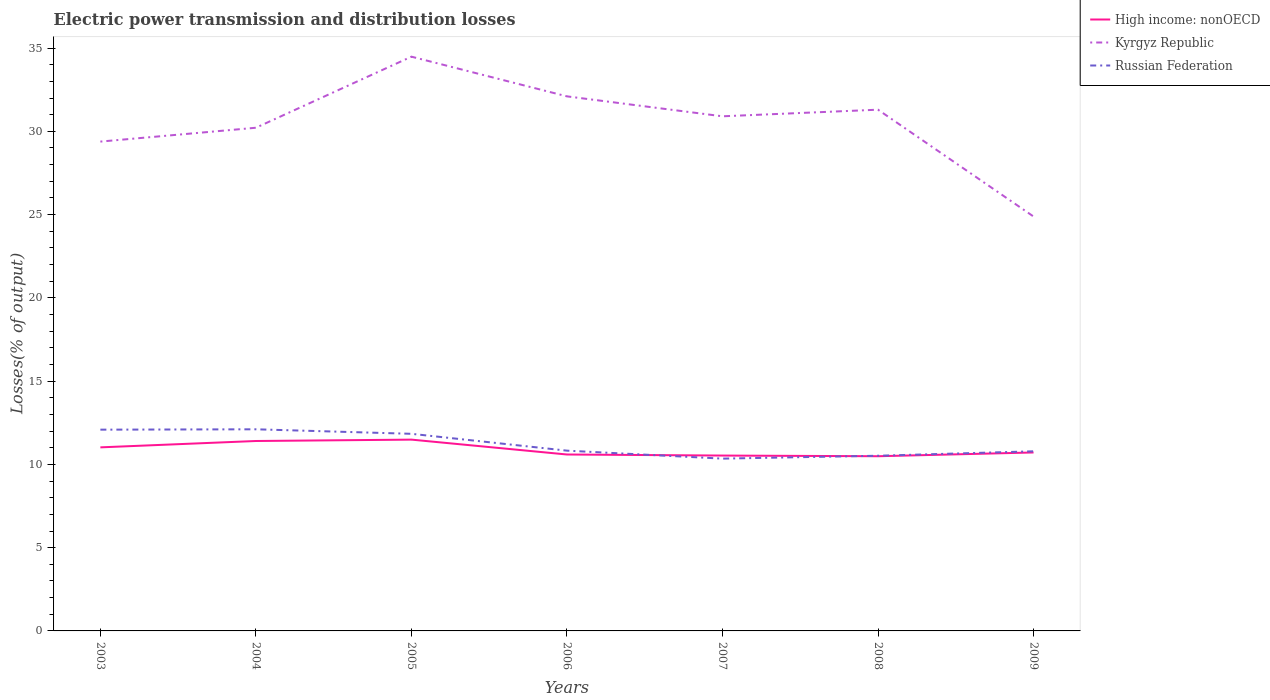Does the line corresponding to Kyrgyz Republic intersect with the line corresponding to High income: nonOECD?
Give a very brief answer. No. Is the number of lines equal to the number of legend labels?
Your response must be concise. Yes. Across all years, what is the maximum electric power transmission and distribution losses in Russian Federation?
Your answer should be compact. 10.35. In which year was the electric power transmission and distribution losses in High income: nonOECD maximum?
Your response must be concise. 2008. What is the total electric power transmission and distribution losses in Russian Federation in the graph?
Your answer should be very brief. -0.02. What is the difference between the highest and the second highest electric power transmission and distribution losses in Kyrgyz Republic?
Offer a very short reply. 9.6. What is the difference between the highest and the lowest electric power transmission and distribution losses in Russian Federation?
Keep it short and to the point. 3. Are the values on the major ticks of Y-axis written in scientific E-notation?
Offer a very short reply. No. Does the graph contain any zero values?
Your answer should be very brief. No. How are the legend labels stacked?
Your response must be concise. Vertical. What is the title of the graph?
Offer a very short reply. Electric power transmission and distribution losses. Does "Belarus" appear as one of the legend labels in the graph?
Offer a very short reply. No. What is the label or title of the X-axis?
Make the answer very short. Years. What is the label or title of the Y-axis?
Make the answer very short. Losses(% of output). What is the Losses(% of output) of High income: nonOECD in 2003?
Your response must be concise. 11.02. What is the Losses(% of output) in Kyrgyz Republic in 2003?
Your answer should be compact. 29.38. What is the Losses(% of output) in Russian Federation in 2003?
Provide a succinct answer. 12.09. What is the Losses(% of output) of High income: nonOECD in 2004?
Offer a very short reply. 11.4. What is the Losses(% of output) of Kyrgyz Republic in 2004?
Ensure brevity in your answer.  30.22. What is the Losses(% of output) of Russian Federation in 2004?
Ensure brevity in your answer.  12.11. What is the Losses(% of output) in High income: nonOECD in 2005?
Offer a terse response. 11.49. What is the Losses(% of output) in Kyrgyz Republic in 2005?
Offer a very short reply. 34.48. What is the Losses(% of output) of Russian Federation in 2005?
Ensure brevity in your answer.  11.84. What is the Losses(% of output) of High income: nonOECD in 2006?
Offer a very short reply. 10.59. What is the Losses(% of output) in Kyrgyz Republic in 2006?
Offer a very short reply. 32.1. What is the Losses(% of output) of Russian Federation in 2006?
Make the answer very short. 10.83. What is the Losses(% of output) of High income: nonOECD in 2007?
Ensure brevity in your answer.  10.53. What is the Losses(% of output) of Kyrgyz Republic in 2007?
Offer a very short reply. 30.9. What is the Losses(% of output) of Russian Federation in 2007?
Ensure brevity in your answer.  10.35. What is the Losses(% of output) in High income: nonOECD in 2008?
Provide a short and direct response. 10.49. What is the Losses(% of output) in Kyrgyz Republic in 2008?
Your response must be concise. 31.3. What is the Losses(% of output) in Russian Federation in 2008?
Offer a very short reply. 10.52. What is the Losses(% of output) in High income: nonOECD in 2009?
Your answer should be compact. 10.72. What is the Losses(% of output) of Kyrgyz Republic in 2009?
Keep it short and to the point. 24.88. What is the Losses(% of output) of Russian Federation in 2009?
Your answer should be very brief. 10.79. Across all years, what is the maximum Losses(% of output) of High income: nonOECD?
Provide a short and direct response. 11.49. Across all years, what is the maximum Losses(% of output) in Kyrgyz Republic?
Keep it short and to the point. 34.48. Across all years, what is the maximum Losses(% of output) in Russian Federation?
Keep it short and to the point. 12.11. Across all years, what is the minimum Losses(% of output) of High income: nonOECD?
Offer a very short reply. 10.49. Across all years, what is the minimum Losses(% of output) of Kyrgyz Republic?
Keep it short and to the point. 24.88. Across all years, what is the minimum Losses(% of output) of Russian Federation?
Provide a succinct answer. 10.35. What is the total Losses(% of output) in High income: nonOECD in the graph?
Offer a very short reply. 76.25. What is the total Losses(% of output) of Kyrgyz Republic in the graph?
Your answer should be compact. 213.27. What is the total Losses(% of output) in Russian Federation in the graph?
Keep it short and to the point. 78.51. What is the difference between the Losses(% of output) in High income: nonOECD in 2003 and that in 2004?
Offer a terse response. -0.38. What is the difference between the Losses(% of output) of Kyrgyz Republic in 2003 and that in 2004?
Make the answer very short. -0.83. What is the difference between the Losses(% of output) in Russian Federation in 2003 and that in 2004?
Provide a succinct answer. -0.02. What is the difference between the Losses(% of output) in High income: nonOECD in 2003 and that in 2005?
Offer a terse response. -0.46. What is the difference between the Losses(% of output) of Kyrgyz Republic in 2003 and that in 2005?
Give a very brief answer. -5.1. What is the difference between the Losses(% of output) of Russian Federation in 2003 and that in 2005?
Provide a short and direct response. 0.25. What is the difference between the Losses(% of output) in High income: nonOECD in 2003 and that in 2006?
Your answer should be compact. 0.43. What is the difference between the Losses(% of output) in Kyrgyz Republic in 2003 and that in 2006?
Your answer should be compact. -2.72. What is the difference between the Losses(% of output) of Russian Federation in 2003 and that in 2006?
Give a very brief answer. 1.26. What is the difference between the Losses(% of output) in High income: nonOECD in 2003 and that in 2007?
Provide a succinct answer. 0.49. What is the difference between the Losses(% of output) in Kyrgyz Republic in 2003 and that in 2007?
Your answer should be compact. -1.52. What is the difference between the Losses(% of output) in Russian Federation in 2003 and that in 2007?
Keep it short and to the point. 1.74. What is the difference between the Losses(% of output) in High income: nonOECD in 2003 and that in 2008?
Keep it short and to the point. 0.53. What is the difference between the Losses(% of output) of Kyrgyz Republic in 2003 and that in 2008?
Keep it short and to the point. -1.92. What is the difference between the Losses(% of output) in Russian Federation in 2003 and that in 2008?
Your response must be concise. 1.57. What is the difference between the Losses(% of output) of High income: nonOECD in 2003 and that in 2009?
Ensure brevity in your answer.  0.31. What is the difference between the Losses(% of output) in Kyrgyz Republic in 2003 and that in 2009?
Offer a terse response. 4.5. What is the difference between the Losses(% of output) in Russian Federation in 2003 and that in 2009?
Provide a short and direct response. 1.3. What is the difference between the Losses(% of output) in High income: nonOECD in 2004 and that in 2005?
Provide a short and direct response. -0.08. What is the difference between the Losses(% of output) of Kyrgyz Republic in 2004 and that in 2005?
Offer a very short reply. -4.27. What is the difference between the Losses(% of output) in Russian Federation in 2004 and that in 2005?
Provide a short and direct response. 0.27. What is the difference between the Losses(% of output) in High income: nonOECD in 2004 and that in 2006?
Your answer should be compact. 0.81. What is the difference between the Losses(% of output) in Kyrgyz Republic in 2004 and that in 2006?
Your answer should be compact. -1.88. What is the difference between the Losses(% of output) in Russian Federation in 2004 and that in 2006?
Give a very brief answer. 1.28. What is the difference between the Losses(% of output) in High income: nonOECD in 2004 and that in 2007?
Provide a short and direct response. 0.87. What is the difference between the Losses(% of output) of Kyrgyz Republic in 2004 and that in 2007?
Offer a very short reply. -0.69. What is the difference between the Losses(% of output) of Russian Federation in 2004 and that in 2007?
Give a very brief answer. 1.76. What is the difference between the Losses(% of output) of High income: nonOECD in 2004 and that in 2008?
Provide a succinct answer. 0.92. What is the difference between the Losses(% of output) of Kyrgyz Republic in 2004 and that in 2008?
Your answer should be very brief. -1.08. What is the difference between the Losses(% of output) in Russian Federation in 2004 and that in 2008?
Provide a succinct answer. 1.59. What is the difference between the Losses(% of output) in High income: nonOECD in 2004 and that in 2009?
Offer a very short reply. 0.69. What is the difference between the Losses(% of output) in Kyrgyz Republic in 2004 and that in 2009?
Provide a succinct answer. 5.33. What is the difference between the Losses(% of output) in Russian Federation in 2004 and that in 2009?
Provide a succinct answer. 1.32. What is the difference between the Losses(% of output) of High income: nonOECD in 2005 and that in 2006?
Offer a terse response. 0.89. What is the difference between the Losses(% of output) of Kyrgyz Republic in 2005 and that in 2006?
Offer a very short reply. 2.38. What is the difference between the Losses(% of output) in Russian Federation in 2005 and that in 2006?
Your answer should be very brief. 1.01. What is the difference between the Losses(% of output) of High income: nonOECD in 2005 and that in 2007?
Provide a short and direct response. 0.96. What is the difference between the Losses(% of output) of Kyrgyz Republic in 2005 and that in 2007?
Give a very brief answer. 3.58. What is the difference between the Losses(% of output) in Russian Federation in 2005 and that in 2007?
Provide a short and direct response. 1.49. What is the difference between the Losses(% of output) in Kyrgyz Republic in 2005 and that in 2008?
Provide a short and direct response. 3.18. What is the difference between the Losses(% of output) of Russian Federation in 2005 and that in 2008?
Your response must be concise. 1.32. What is the difference between the Losses(% of output) of High income: nonOECD in 2005 and that in 2009?
Your response must be concise. 0.77. What is the difference between the Losses(% of output) in Kyrgyz Republic in 2005 and that in 2009?
Your answer should be compact. 9.6. What is the difference between the Losses(% of output) of Russian Federation in 2005 and that in 2009?
Keep it short and to the point. 1.05. What is the difference between the Losses(% of output) in High income: nonOECD in 2006 and that in 2007?
Offer a very short reply. 0.06. What is the difference between the Losses(% of output) of Kyrgyz Republic in 2006 and that in 2007?
Offer a very short reply. 1.2. What is the difference between the Losses(% of output) of Russian Federation in 2006 and that in 2007?
Make the answer very short. 0.48. What is the difference between the Losses(% of output) of High income: nonOECD in 2006 and that in 2008?
Ensure brevity in your answer.  0.1. What is the difference between the Losses(% of output) in Kyrgyz Republic in 2006 and that in 2008?
Offer a very short reply. 0.8. What is the difference between the Losses(% of output) in Russian Federation in 2006 and that in 2008?
Your response must be concise. 0.31. What is the difference between the Losses(% of output) in High income: nonOECD in 2006 and that in 2009?
Your answer should be very brief. -0.12. What is the difference between the Losses(% of output) in Kyrgyz Republic in 2006 and that in 2009?
Provide a succinct answer. 7.22. What is the difference between the Losses(% of output) in Russian Federation in 2006 and that in 2009?
Make the answer very short. 0.04. What is the difference between the Losses(% of output) of High income: nonOECD in 2007 and that in 2008?
Offer a very short reply. 0.04. What is the difference between the Losses(% of output) in Kyrgyz Republic in 2007 and that in 2008?
Your answer should be very brief. -0.4. What is the difference between the Losses(% of output) in Russian Federation in 2007 and that in 2008?
Make the answer very short. -0.17. What is the difference between the Losses(% of output) of High income: nonOECD in 2007 and that in 2009?
Your answer should be very brief. -0.19. What is the difference between the Losses(% of output) in Kyrgyz Republic in 2007 and that in 2009?
Offer a very short reply. 6.02. What is the difference between the Losses(% of output) of Russian Federation in 2007 and that in 2009?
Give a very brief answer. -0.44. What is the difference between the Losses(% of output) in High income: nonOECD in 2008 and that in 2009?
Make the answer very short. -0.23. What is the difference between the Losses(% of output) in Kyrgyz Republic in 2008 and that in 2009?
Make the answer very short. 6.42. What is the difference between the Losses(% of output) of Russian Federation in 2008 and that in 2009?
Provide a short and direct response. -0.27. What is the difference between the Losses(% of output) in High income: nonOECD in 2003 and the Losses(% of output) in Kyrgyz Republic in 2004?
Provide a succinct answer. -19.19. What is the difference between the Losses(% of output) of High income: nonOECD in 2003 and the Losses(% of output) of Russian Federation in 2004?
Offer a terse response. -1.08. What is the difference between the Losses(% of output) of Kyrgyz Republic in 2003 and the Losses(% of output) of Russian Federation in 2004?
Your answer should be very brief. 17.28. What is the difference between the Losses(% of output) in High income: nonOECD in 2003 and the Losses(% of output) in Kyrgyz Republic in 2005?
Ensure brevity in your answer.  -23.46. What is the difference between the Losses(% of output) in High income: nonOECD in 2003 and the Losses(% of output) in Russian Federation in 2005?
Keep it short and to the point. -0.81. What is the difference between the Losses(% of output) of Kyrgyz Republic in 2003 and the Losses(% of output) of Russian Federation in 2005?
Provide a short and direct response. 17.55. What is the difference between the Losses(% of output) of High income: nonOECD in 2003 and the Losses(% of output) of Kyrgyz Republic in 2006?
Give a very brief answer. -21.08. What is the difference between the Losses(% of output) in High income: nonOECD in 2003 and the Losses(% of output) in Russian Federation in 2006?
Give a very brief answer. 0.2. What is the difference between the Losses(% of output) in Kyrgyz Republic in 2003 and the Losses(% of output) in Russian Federation in 2006?
Make the answer very short. 18.56. What is the difference between the Losses(% of output) in High income: nonOECD in 2003 and the Losses(% of output) in Kyrgyz Republic in 2007?
Make the answer very short. -19.88. What is the difference between the Losses(% of output) in High income: nonOECD in 2003 and the Losses(% of output) in Russian Federation in 2007?
Offer a very short reply. 0.68. What is the difference between the Losses(% of output) in Kyrgyz Republic in 2003 and the Losses(% of output) in Russian Federation in 2007?
Your answer should be very brief. 19.04. What is the difference between the Losses(% of output) in High income: nonOECD in 2003 and the Losses(% of output) in Kyrgyz Republic in 2008?
Your response must be concise. -20.28. What is the difference between the Losses(% of output) of High income: nonOECD in 2003 and the Losses(% of output) of Russian Federation in 2008?
Provide a short and direct response. 0.5. What is the difference between the Losses(% of output) of Kyrgyz Republic in 2003 and the Losses(% of output) of Russian Federation in 2008?
Make the answer very short. 18.86. What is the difference between the Losses(% of output) of High income: nonOECD in 2003 and the Losses(% of output) of Kyrgyz Republic in 2009?
Provide a succinct answer. -13.86. What is the difference between the Losses(% of output) of High income: nonOECD in 2003 and the Losses(% of output) of Russian Federation in 2009?
Provide a short and direct response. 0.24. What is the difference between the Losses(% of output) of Kyrgyz Republic in 2003 and the Losses(% of output) of Russian Federation in 2009?
Provide a succinct answer. 18.6. What is the difference between the Losses(% of output) of High income: nonOECD in 2004 and the Losses(% of output) of Kyrgyz Republic in 2005?
Provide a short and direct response. -23.08. What is the difference between the Losses(% of output) of High income: nonOECD in 2004 and the Losses(% of output) of Russian Federation in 2005?
Offer a terse response. -0.43. What is the difference between the Losses(% of output) in Kyrgyz Republic in 2004 and the Losses(% of output) in Russian Federation in 2005?
Provide a short and direct response. 18.38. What is the difference between the Losses(% of output) in High income: nonOECD in 2004 and the Losses(% of output) in Kyrgyz Republic in 2006?
Your response must be concise. -20.7. What is the difference between the Losses(% of output) in High income: nonOECD in 2004 and the Losses(% of output) in Russian Federation in 2006?
Give a very brief answer. 0.58. What is the difference between the Losses(% of output) in Kyrgyz Republic in 2004 and the Losses(% of output) in Russian Federation in 2006?
Your answer should be compact. 19.39. What is the difference between the Losses(% of output) of High income: nonOECD in 2004 and the Losses(% of output) of Kyrgyz Republic in 2007?
Offer a very short reply. -19.5. What is the difference between the Losses(% of output) of High income: nonOECD in 2004 and the Losses(% of output) of Russian Federation in 2007?
Your response must be concise. 1.06. What is the difference between the Losses(% of output) of Kyrgyz Republic in 2004 and the Losses(% of output) of Russian Federation in 2007?
Provide a short and direct response. 19.87. What is the difference between the Losses(% of output) of High income: nonOECD in 2004 and the Losses(% of output) of Kyrgyz Republic in 2008?
Keep it short and to the point. -19.9. What is the difference between the Losses(% of output) of High income: nonOECD in 2004 and the Losses(% of output) of Russian Federation in 2008?
Provide a short and direct response. 0.89. What is the difference between the Losses(% of output) of Kyrgyz Republic in 2004 and the Losses(% of output) of Russian Federation in 2008?
Keep it short and to the point. 19.7. What is the difference between the Losses(% of output) of High income: nonOECD in 2004 and the Losses(% of output) of Kyrgyz Republic in 2009?
Ensure brevity in your answer.  -13.48. What is the difference between the Losses(% of output) in High income: nonOECD in 2004 and the Losses(% of output) in Russian Federation in 2009?
Provide a succinct answer. 0.62. What is the difference between the Losses(% of output) of Kyrgyz Republic in 2004 and the Losses(% of output) of Russian Federation in 2009?
Your answer should be very brief. 19.43. What is the difference between the Losses(% of output) in High income: nonOECD in 2005 and the Losses(% of output) in Kyrgyz Republic in 2006?
Provide a succinct answer. -20.61. What is the difference between the Losses(% of output) of High income: nonOECD in 2005 and the Losses(% of output) of Russian Federation in 2006?
Offer a very short reply. 0.66. What is the difference between the Losses(% of output) in Kyrgyz Republic in 2005 and the Losses(% of output) in Russian Federation in 2006?
Your answer should be very brief. 23.66. What is the difference between the Losses(% of output) in High income: nonOECD in 2005 and the Losses(% of output) in Kyrgyz Republic in 2007?
Ensure brevity in your answer.  -19.42. What is the difference between the Losses(% of output) of High income: nonOECD in 2005 and the Losses(% of output) of Russian Federation in 2007?
Keep it short and to the point. 1.14. What is the difference between the Losses(% of output) in Kyrgyz Republic in 2005 and the Losses(% of output) in Russian Federation in 2007?
Your answer should be compact. 24.14. What is the difference between the Losses(% of output) of High income: nonOECD in 2005 and the Losses(% of output) of Kyrgyz Republic in 2008?
Keep it short and to the point. -19.81. What is the difference between the Losses(% of output) in High income: nonOECD in 2005 and the Losses(% of output) in Russian Federation in 2008?
Give a very brief answer. 0.97. What is the difference between the Losses(% of output) of Kyrgyz Republic in 2005 and the Losses(% of output) of Russian Federation in 2008?
Provide a short and direct response. 23.96. What is the difference between the Losses(% of output) of High income: nonOECD in 2005 and the Losses(% of output) of Kyrgyz Republic in 2009?
Your answer should be compact. -13.4. What is the difference between the Losses(% of output) of High income: nonOECD in 2005 and the Losses(% of output) of Russian Federation in 2009?
Your answer should be compact. 0.7. What is the difference between the Losses(% of output) of Kyrgyz Republic in 2005 and the Losses(% of output) of Russian Federation in 2009?
Provide a succinct answer. 23.7. What is the difference between the Losses(% of output) in High income: nonOECD in 2006 and the Losses(% of output) in Kyrgyz Republic in 2007?
Offer a terse response. -20.31. What is the difference between the Losses(% of output) of High income: nonOECD in 2006 and the Losses(% of output) of Russian Federation in 2007?
Your answer should be compact. 0.25. What is the difference between the Losses(% of output) in Kyrgyz Republic in 2006 and the Losses(% of output) in Russian Federation in 2007?
Your answer should be compact. 21.75. What is the difference between the Losses(% of output) of High income: nonOECD in 2006 and the Losses(% of output) of Kyrgyz Republic in 2008?
Keep it short and to the point. -20.71. What is the difference between the Losses(% of output) of High income: nonOECD in 2006 and the Losses(% of output) of Russian Federation in 2008?
Offer a terse response. 0.07. What is the difference between the Losses(% of output) of Kyrgyz Republic in 2006 and the Losses(% of output) of Russian Federation in 2008?
Your answer should be very brief. 21.58. What is the difference between the Losses(% of output) of High income: nonOECD in 2006 and the Losses(% of output) of Kyrgyz Republic in 2009?
Your response must be concise. -14.29. What is the difference between the Losses(% of output) in High income: nonOECD in 2006 and the Losses(% of output) in Russian Federation in 2009?
Keep it short and to the point. -0.19. What is the difference between the Losses(% of output) of Kyrgyz Republic in 2006 and the Losses(% of output) of Russian Federation in 2009?
Give a very brief answer. 21.31. What is the difference between the Losses(% of output) in High income: nonOECD in 2007 and the Losses(% of output) in Kyrgyz Republic in 2008?
Your response must be concise. -20.77. What is the difference between the Losses(% of output) in High income: nonOECD in 2007 and the Losses(% of output) in Russian Federation in 2008?
Keep it short and to the point. 0.01. What is the difference between the Losses(% of output) in Kyrgyz Republic in 2007 and the Losses(% of output) in Russian Federation in 2008?
Your answer should be very brief. 20.38. What is the difference between the Losses(% of output) of High income: nonOECD in 2007 and the Losses(% of output) of Kyrgyz Republic in 2009?
Offer a very short reply. -14.35. What is the difference between the Losses(% of output) of High income: nonOECD in 2007 and the Losses(% of output) of Russian Federation in 2009?
Keep it short and to the point. -0.26. What is the difference between the Losses(% of output) in Kyrgyz Republic in 2007 and the Losses(% of output) in Russian Federation in 2009?
Ensure brevity in your answer.  20.12. What is the difference between the Losses(% of output) of High income: nonOECD in 2008 and the Losses(% of output) of Kyrgyz Republic in 2009?
Give a very brief answer. -14.4. What is the difference between the Losses(% of output) of High income: nonOECD in 2008 and the Losses(% of output) of Russian Federation in 2009?
Offer a terse response. -0.3. What is the difference between the Losses(% of output) of Kyrgyz Republic in 2008 and the Losses(% of output) of Russian Federation in 2009?
Offer a very short reply. 20.51. What is the average Losses(% of output) of High income: nonOECD per year?
Make the answer very short. 10.89. What is the average Losses(% of output) of Kyrgyz Republic per year?
Offer a very short reply. 30.47. What is the average Losses(% of output) in Russian Federation per year?
Keep it short and to the point. 11.22. In the year 2003, what is the difference between the Losses(% of output) of High income: nonOECD and Losses(% of output) of Kyrgyz Republic?
Your answer should be compact. -18.36. In the year 2003, what is the difference between the Losses(% of output) of High income: nonOECD and Losses(% of output) of Russian Federation?
Provide a succinct answer. -1.06. In the year 2003, what is the difference between the Losses(% of output) in Kyrgyz Republic and Losses(% of output) in Russian Federation?
Your answer should be very brief. 17.3. In the year 2004, what is the difference between the Losses(% of output) of High income: nonOECD and Losses(% of output) of Kyrgyz Republic?
Give a very brief answer. -18.81. In the year 2004, what is the difference between the Losses(% of output) of High income: nonOECD and Losses(% of output) of Russian Federation?
Keep it short and to the point. -0.7. In the year 2004, what is the difference between the Losses(% of output) in Kyrgyz Republic and Losses(% of output) in Russian Federation?
Make the answer very short. 18.11. In the year 2005, what is the difference between the Losses(% of output) of High income: nonOECD and Losses(% of output) of Kyrgyz Republic?
Provide a succinct answer. -23. In the year 2005, what is the difference between the Losses(% of output) in High income: nonOECD and Losses(% of output) in Russian Federation?
Your response must be concise. -0.35. In the year 2005, what is the difference between the Losses(% of output) of Kyrgyz Republic and Losses(% of output) of Russian Federation?
Your answer should be compact. 22.65. In the year 2006, what is the difference between the Losses(% of output) in High income: nonOECD and Losses(% of output) in Kyrgyz Republic?
Give a very brief answer. -21.51. In the year 2006, what is the difference between the Losses(% of output) of High income: nonOECD and Losses(% of output) of Russian Federation?
Ensure brevity in your answer.  -0.23. In the year 2006, what is the difference between the Losses(% of output) of Kyrgyz Republic and Losses(% of output) of Russian Federation?
Provide a succinct answer. 21.28. In the year 2007, what is the difference between the Losses(% of output) of High income: nonOECD and Losses(% of output) of Kyrgyz Republic?
Your response must be concise. -20.37. In the year 2007, what is the difference between the Losses(% of output) in High income: nonOECD and Losses(% of output) in Russian Federation?
Your answer should be very brief. 0.18. In the year 2007, what is the difference between the Losses(% of output) in Kyrgyz Republic and Losses(% of output) in Russian Federation?
Your answer should be compact. 20.56. In the year 2008, what is the difference between the Losses(% of output) of High income: nonOECD and Losses(% of output) of Kyrgyz Republic?
Provide a short and direct response. -20.81. In the year 2008, what is the difference between the Losses(% of output) in High income: nonOECD and Losses(% of output) in Russian Federation?
Give a very brief answer. -0.03. In the year 2008, what is the difference between the Losses(% of output) in Kyrgyz Republic and Losses(% of output) in Russian Federation?
Offer a terse response. 20.78. In the year 2009, what is the difference between the Losses(% of output) of High income: nonOECD and Losses(% of output) of Kyrgyz Republic?
Provide a short and direct response. -14.17. In the year 2009, what is the difference between the Losses(% of output) in High income: nonOECD and Losses(% of output) in Russian Federation?
Keep it short and to the point. -0.07. In the year 2009, what is the difference between the Losses(% of output) in Kyrgyz Republic and Losses(% of output) in Russian Federation?
Provide a short and direct response. 14.1. What is the ratio of the Losses(% of output) of High income: nonOECD in 2003 to that in 2004?
Your response must be concise. 0.97. What is the ratio of the Losses(% of output) of Kyrgyz Republic in 2003 to that in 2004?
Offer a terse response. 0.97. What is the ratio of the Losses(% of output) of Russian Federation in 2003 to that in 2004?
Make the answer very short. 1. What is the ratio of the Losses(% of output) of High income: nonOECD in 2003 to that in 2005?
Provide a succinct answer. 0.96. What is the ratio of the Losses(% of output) in Kyrgyz Republic in 2003 to that in 2005?
Give a very brief answer. 0.85. What is the ratio of the Losses(% of output) of High income: nonOECD in 2003 to that in 2006?
Ensure brevity in your answer.  1.04. What is the ratio of the Losses(% of output) of Kyrgyz Republic in 2003 to that in 2006?
Provide a succinct answer. 0.92. What is the ratio of the Losses(% of output) of Russian Federation in 2003 to that in 2006?
Your answer should be compact. 1.12. What is the ratio of the Losses(% of output) in High income: nonOECD in 2003 to that in 2007?
Your answer should be very brief. 1.05. What is the ratio of the Losses(% of output) of Kyrgyz Republic in 2003 to that in 2007?
Your response must be concise. 0.95. What is the ratio of the Losses(% of output) in Russian Federation in 2003 to that in 2007?
Your answer should be compact. 1.17. What is the ratio of the Losses(% of output) of High income: nonOECD in 2003 to that in 2008?
Provide a succinct answer. 1.05. What is the ratio of the Losses(% of output) in Kyrgyz Republic in 2003 to that in 2008?
Make the answer very short. 0.94. What is the ratio of the Losses(% of output) in Russian Federation in 2003 to that in 2008?
Give a very brief answer. 1.15. What is the ratio of the Losses(% of output) in High income: nonOECD in 2003 to that in 2009?
Your answer should be compact. 1.03. What is the ratio of the Losses(% of output) of Kyrgyz Republic in 2003 to that in 2009?
Ensure brevity in your answer.  1.18. What is the ratio of the Losses(% of output) in Russian Federation in 2003 to that in 2009?
Offer a very short reply. 1.12. What is the ratio of the Losses(% of output) of Kyrgyz Republic in 2004 to that in 2005?
Provide a succinct answer. 0.88. What is the ratio of the Losses(% of output) of Russian Federation in 2004 to that in 2005?
Keep it short and to the point. 1.02. What is the ratio of the Losses(% of output) in High income: nonOECD in 2004 to that in 2006?
Offer a very short reply. 1.08. What is the ratio of the Losses(% of output) in Kyrgyz Republic in 2004 to that in 2006?
Offer a terse response. 0.94. What is the ratio of the Losses(% of output) of Russian Federation in 2004 to that in 2006?
Give a very brief answer. 1.12. What is the ratio of the Losses(% of output) in High income: nonOECD in 2004 to that in 2007?
Provide a short and direct response. 1.08. What is the ratio of the Losses(% of output) of Kyrgyz Republic in 2004 to that in 2007?
Provide a succinct answer. 0.98. What is the ratio of the Losses(% of output) in Russian Federation in 2004 to that in 2007?
Offer a very short reply. 1.17. What is the ratio of the Losses(% of output) in High income: nonOECD in 2004 to that in 2008?
Your answer should be very brief. 1.09. What is the ratio of the Losses(% of output) in Kyrgyz Republic in 2004 to that in 2008?
Ensure brevity in your answer.  0.97. What is the ratio of the Losses(% of output) in Russian Federation in 2004 to that in 2008?
Give a very brief answer. 1.15. What is the ratio of the Losses(% of output) in High income: nonOECD in 2004 to that in 2009?
Your answer should be compact. 1.06. What is the ratio of the Losses(% of output) of Kyrgyz Republic in 2004 to that in 2009?
Provide a succinct answer. 1.21. What is the ratio of the Losses(% of output) in Russian Federation in 2004 to that in 2009?
Give a very brief answer. 1.12. What is the ratio of the Losses(% of output) of High income: nonOECD in 2005 to that in 2006?
Keep it short and to the point. 1.08. What is the ratio of the Losses(% of output) in Kyrgyz Republic in 2005 to that in 2006?
Give a very brief answer. 1.07. What is the ratio of the Losses(% of output) of Russian Federation in 2005 to that in 2006?
Ensure brevity in your answer.  1.09. What is the ratio of the Losses(% of output) in High income: nonOECD in 2005 to that in 2007?
Ensure brevity in your answer.  1.09. What is the ratio of the Losses(% of output) of Kyrgyz Republic in 2005 to that in 2007?
Offer a terse response. 1.12. What is the ratio of the Losses(% of output) of Russian Federation in 2005 to that in 2007?
Your answer should be very brief. 1.14. What is the ratio of the Losses(% of output) in High income: nonOECD in 2005 to that in 2008?
Ensure brevity in your answer.  1.1. What is the ratio of the Losses(% of output) in Kyrgyz Republic in 2005 to that in 2008?
Keep it short and to the point. 1.1. What is the ratio of the Losses(% of output) in Russian Federation in 2005 to that in 2008?
Give a very brief answer. 1.13. What is the ratio of the Losses(% of output) in High income: nonOECD in 2005 to that in 2009?
Provide a short and direct response. 1.07. What is the ratio of the Losses(% of output) of Kyrgyz Republic in 2005 to that in 2009?
Keep it short and to the point. 1.39. What is the ratio of the Losses(% of output) of Russian Federation in 2005 to that in 2009?
Your answer should be compact. 1.1. What is the ratio of the Losses(% of output) of High income: nonOECD in 2006 to that in 2007?
Your answer should be compact. 1.01. What is the ratio of the Losses(% of output) in Kyrgyz Republic in 2006 to that in 2007?
Give a very brief answer. 1.04. What is the ratio of the Losses(% of output) of Russian Federation in 2006 to that in 2007?
Ensure brevity in your answer.  1.05. What is the ratio of the Losses(% of output) in High income: nonOECD in 2006 to that in 2008?
Ensure brevity in your answer.  1.01. What is the ratio of the Losses(% of output) of Kyrgyz Republic in 2006 to that in 2008?
Your answer should be very brief. 1.03. What is the ratio of the Losses(% of output) of High income: nonOECD in 2006 to that in 2009?
Your response must be concise. 0.99. What is the ratio of the Losses(% of output) in Kyrgyz Republic in 2006 to that in 2009?
Offer a terse response. 1.29. What is the ratio of the Losses(% of output) of Kyrgyz Republic in 2007 to that in 2008?
Make the answer very short. 0.99. What is the ratio of the Losses(% of output) in Russian Federation in 2007 to that in 2008?
Make the answer very short. 0.98. What is the ratio of the Losses(% of output) of High income: nonOECD in 2007 to that in 2009?
Ensure brevity in your answer.  0.98. What is the ratio of the Losses(% of output) of Kyrgyz Republic in 2007 to that in 2009?
Keep it short and to the point. 1.24. What is the ratio of the Losses(% of output) of Russian Federation in 2007 to that in 2009?
Give a very brief answer. 0.96. What is the ratio of the Losses(% of output) in High income: nonOECD in 2008 to that in 2009?
Give a very brief answer. 0.98. What is the ratio of the Losses(% of output) of Kyrgyz Republic in 2008 to that in 2009?
Provide a succinct answer. 1.26. What is the ratio of the Losses(% of output) of Russian Federation in 2008 to that in 2009?
Provide a short and direct response. 0.98. What is the difference between the highest and the second highest Losses(% of output) of High income: nonOECD?
Your answer should be compact. 0.08. What is the difference between the highest and the second highest Losses(% of output) in Kyrgyz Republic?
Make the answer very short. 2.38. What is the difference between the highest and the second highest Losses(% of output) in Russian Federation?
Offer a very short reply. 0.02. What is the difference between the highest and the lowest Losses(% of output) in High income: nonOECD?
Give a very brief answer. 1. What is the difference between the highest and the lowest Losses(% of output) in Kyrgyz Republic?
Offer a very short reply. 9.6. What is the difference between the highest and the lowest Losses(% of output) in Russian Federation?
Make the answer very short. 1.76. 